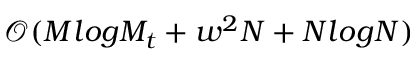<formula> <loc_0><loc_0><loc_500><loc_500>\mathcal { O } ( M \log M _ { t } + w ^ { 2 } N + N \log N )</formula> 